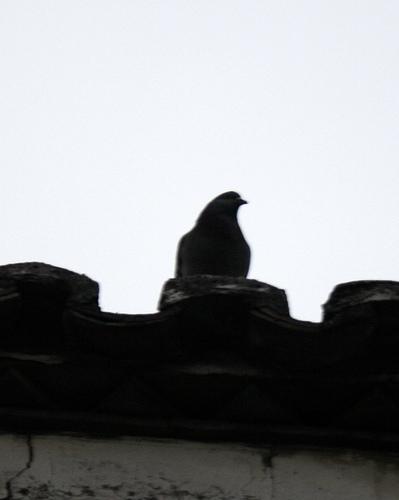Is it day or night in this picture?
Write a very short answer. Day. Is this a bird that Coos?
Concise answer only. Yes. Is this photo blurry?
Write a very short answer. Yes. 